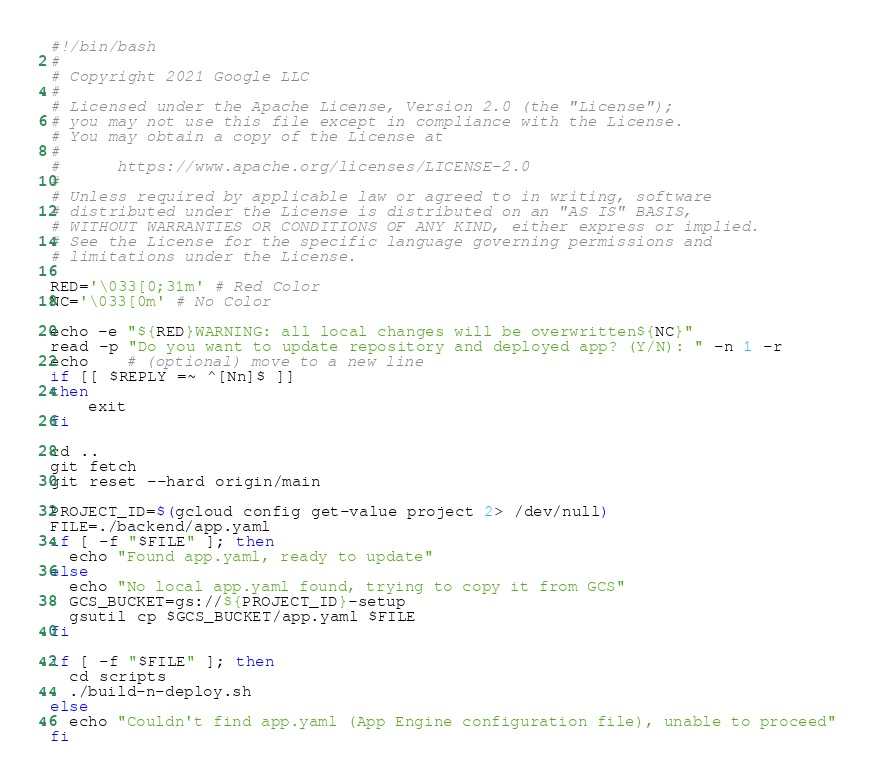<code> <loc_0><loc_0><loc_500><loc_500><_Bash_>#!/bin/bash
#
# Copyright 2021 Google LLC
#
# Licensed under the Apache License, Version 2.0 (the "License");
# you may not use this file except in compliance with the License.
# You may obtain a copy of the License at
#
#      https://www.apache.org/licenses/LICENSE-2.0
#
# Unless required by applicable law or agreed to in writing, software
# distributed under the License is distributed on an "AS IS" BASIS,
# WITHOUT WARRANTIES OR CONDITIONS OF ANY KIND, either express or implied.
# See the License for the specific language governing permissions and
# limitations under the License.

RED='\033[0;31m' # Red Color
NC='\033[0m' # No Color

echo -e "${RED}WARNING: all local changes will be overwritten${NC}"
read -p "Do you want to update repository and deployed app? (Y/N): " -n 1 -r
echo    # (optional) move to a new line
if [[ $REPLY =~ ^[Nn]$ ]]
then
    exit
fi

cd ..
git fetch
git reset --hard origin/main

PROJECT_ID=$(gcloud config get-value project 2> /dev/null)
FILE=./backend/app.yaml
if [ -f "$FILE" ]; then
  echo "Found app.yaml, ready to update"
else
  echo "No local app.yaml found, trying to copy it from GCS"
  GCS_BUCKET=gs://${PROJECT_ID}-setup
  gsutil cp $GCS_BUCKET/app.yaml $FILE
fi

if [ -f "$FILE" ]; then
  cd scripts
  ./build-n-deploy.sh
else
  echo "Couldn't find app.yaml (App Engine configuration file), unable to proceed"
fi

</code> 